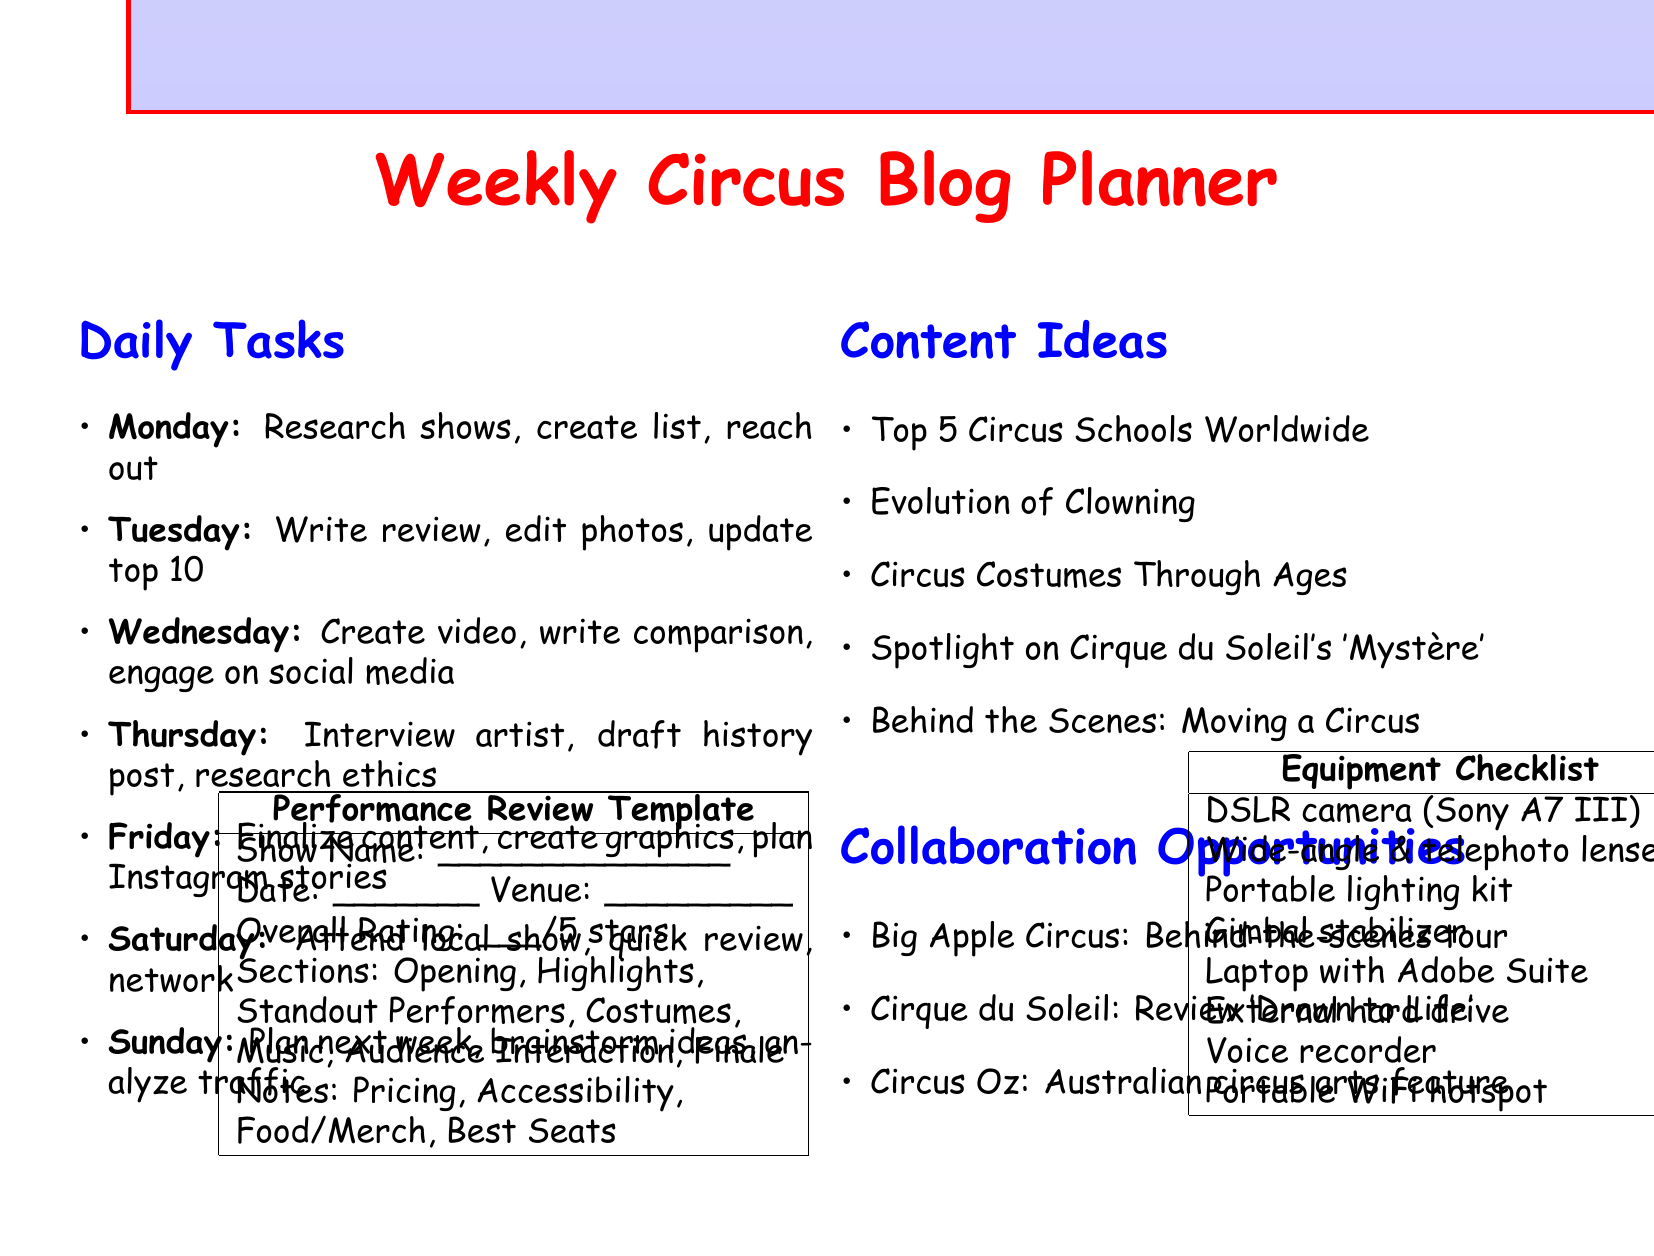What tasks are scheduled for Thursday? The document lists three specific tasks for Thursday, including interviewing a trapeze artist and drafting a history post.
Answer: Interview a trapeze artist from Cirque Éloize, draft a post about the history of Circus Krone in Munich, research and write about ethical animal treatment in modern circuses How many tasks are scheduled for Saturday? Saturday has three specific tasks planned, which include attending a circus performance and writing a review.
Answer: 3 Which circus performance is being reviewed on Tuesday? The document specifies that a detailed review of Cirque du Soleil's 'O' show is to be written on Tuesday.
Answer: Cirque du Soleil's 'O' show What is one proposed content idea? The document lists several content ideas, among which there are titles like "The Evolution of Clowning."
Answer: Top 5 Circus Schools Around the World for Aspiring Performers What is the overall rating format in the performance review template? The template outlines that the overall rating should be given out of five stars.
Answer: /5 stars What equipment is required for conducting interviews according to the checklist? The checklist mentions a voice recorder as essential equipment for interviews.
Answer: Voice recorder What company is offering an exclusive behind-the-scenes tour opportunity? The document identifies Big Apple Circus as the company connected to an exclusive tour opportunity.
Answer: Big Apple Circus What day is dedicated to attending a local circus performance? According to the schedule, Saturday is the day designated for attending a local circus performance.
Answer: Saturday 